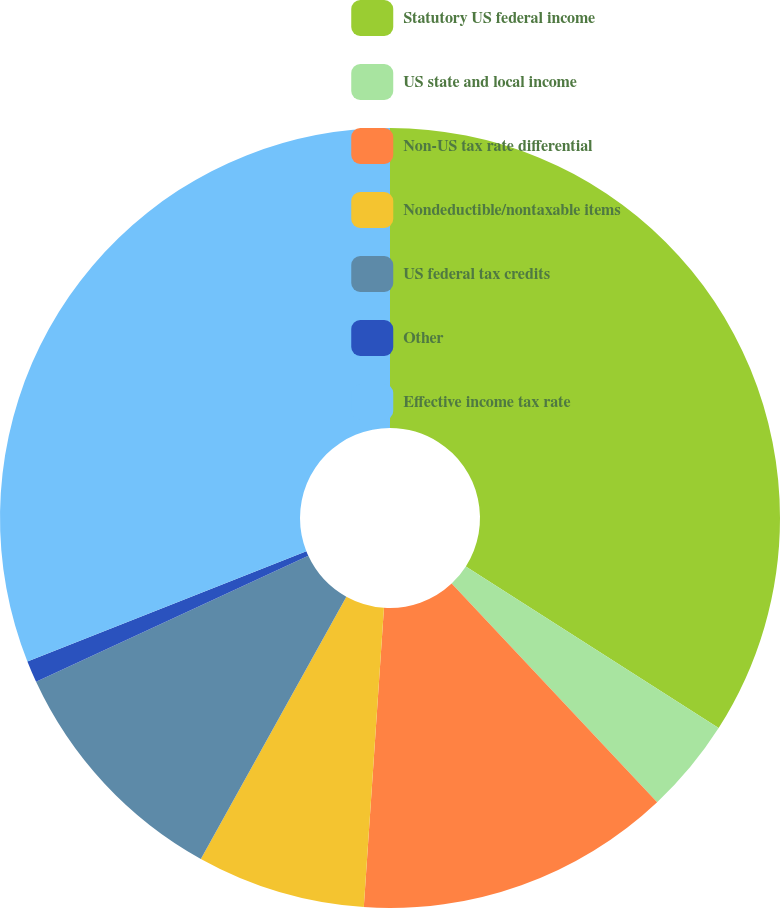<chart> <loc_0><loc_0><loc_500><loc_500><pie_chart><fcel>Statutory US federal income<fcel>US state and local income<fcel>Non-US tax rate differential<fcel>Nondeductible/nontaxable items<fcel>US federal tax credits<fcel>Other<fcel>Effective income tax rate<nl><fcel>34.05%<fcel>3.94%<fcel>13.08%<fcel>6.99%<fcel>10.04%<fcel>0.9%<fcel>31.0%<nl></chart> 